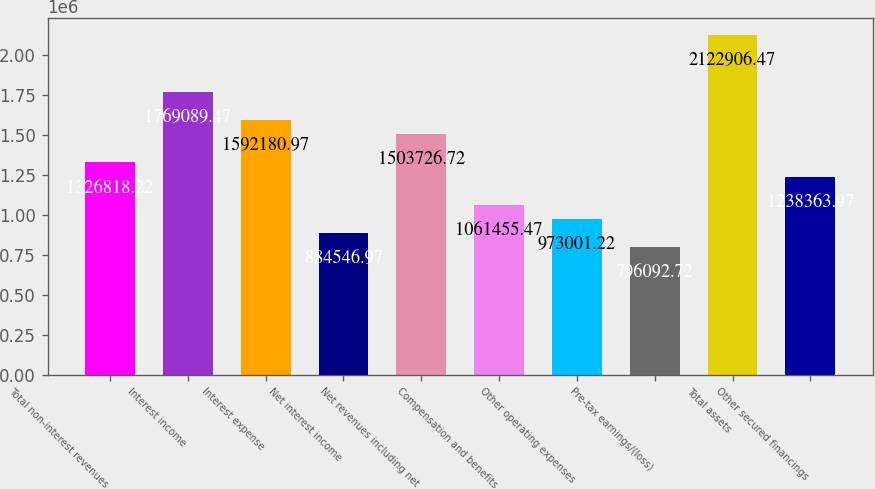Convert chart to OTSL. <chart><loc_0><loc_0><loc_500><loc_500><bar_chart><fcel>Total non-interest revenues<fcel>Interest income<fcel>Interest expense<fcel>Net interest income<fcel>Net revenues including net<fcel>Compensation and benefits<fcel>Other operating expenses<fcel>Pre-tax earnings/(loss)<fcel>Total assets<fcel>Other secured financings<nl><fcel>1.32682e+06<fcel>1.76909e+06<fcel>1.59218e+06<fcel>884547<fcel>1.50373e+06<fcel>1.06146e+06<fcel>973001<fcel>796093<fcel>2.12291e+06<fcel>1.23836e+06<nl></chart> 